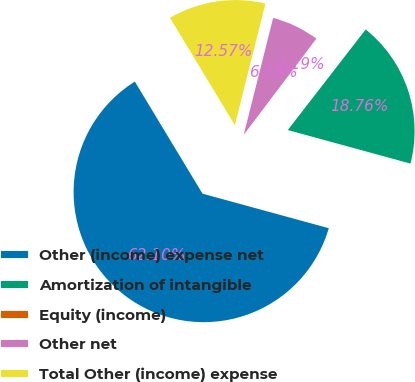<chart> <loc_0><loc_0><loc_500><loc_500><pie_chart><fcel>Other (income) expense net<fcel>Amortization of intangible<fcel>Equity (income)<fcel>Other net<fcel>Total Other (income) expense<nl><fcel>62.11%<fcel>18.76%<fcel>0.19%<fcel>6.38%<fcel>12.57%<nl></chart> 